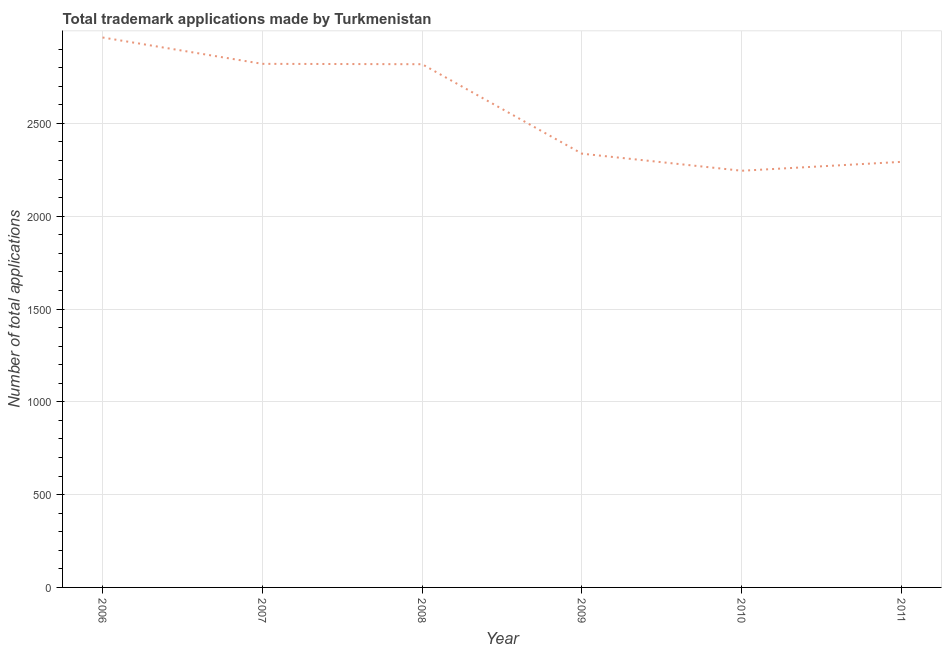What is the number of trademark applications in 2011?
Give a very brief answer. 2293. Across all years, what is the maximum number of trademark applications?
Keep it short and to the point. 2963. Across all years, what is the minimum number of trademark applications?
Your answer should be very brief. 2245. In which year was the number of trademark applications maximum?
Your answer should be very brief. 2006. In which year was the number of trademark applications minimum?
Offer a very short reply. 2010. What is the sum of the number of trademark applications?
Your answer should be compact. 1.55e+04. What is the difference between the number of trademark applications in 2008 and 2010?
Keep it short and to the point. 574. What is the average number of trademark applications per year?
Offer a terse response. 2579.67. What is the median number of trademark applications?
Give a very brief answer. 2578. In how many years, is the number of trademark applications greater than 1600 ?
Your response must be concise. 6. What is the ratio of the number of trademark applications in 2008 to that in 2011?
Offer a very short reply. 1.23. Is the difference between the number of trademark applications in 2009 and 2011 greater than the difference between any two years?
Give a very brief answer. No. What is the difference between the highest and the second highest number of trademark applications?
Your answer should be very brief. 142. What is the difference between the highest and the lowest number of trademark applications?
Offer a terse response. 718. Are the values on the major ticks of Y-axis written in scientific E-notation?
Make the answer very short. No. Does the graph contain any zero values?
Your answer should be compact. No. What is the title of the graph?
Give a very brief answer. Total trademark applications made by Turkmenistan. What is the label or title of the Y-axis?
Make the answer very short. Number of total applications. What is the Number of total applications of 2006?
Ensure brevity in your answer.  2963. What is the Number of total applications in 2007?
Make the answer very short. 2821. What is the Number of total applications of 2008?
Offer a very short reply. 2819. What is the Number of total applications in 2009?
Make the answer very short. 2337. What is the Number of total applications of 2010?
Provide a short and direct response. 2245. What is the Number of total applications of 2011?
Make the answer very short. 2293. What is the difference between the Number of total applications in 2006 and 2007?
Provide a short and direct response. 142. What is the difference between the Number of total applications in 2006 and 2008?
Ensure brevity in your answer.  144. What is the difference between the Number of total applications in 2006 and 2009?
Give a very brief answer. 626. What is the difference between the Number of total applications in 2006 and 2010?
Offer a very short reply. 718. What is the difference between the Number of total applications in 2006 and 2011?
Your answer should be very brief. 670. What is the difference between the Number of total applications in 2007 and 2009?
Your answer should be very brief. 484. What is the difference between the Number of total applications in 2007 and 2010?
Provide a short and direct response. 576. What is the difference between the Number of total applications in 2007 and 2011?
Your response must be concise. 528. What is the difference between the Number of total applications in 2008 and 2009?
Offer a very short reply. 482. What is the difference between the Number of total applications in 2008 and 2010?
Provide a short and direct response. 574. What is the difference between the Number of total applications in 2008 and 2011?
Provide a succinct answer. 526. What is the difference between the Number of total applications in 2009 and 2010?
Provide a succinct answer. 92. What is the difference between the Number of total applications in 2010 and 2011?
Keep it short and to the point. -48. What is the ratio of the Number of total applications in 2006 to that in 2008?
Offer a very short reply. 1.05. What is the ratio of the Number of total applications in 2006 to that in 2009?
Ensure brevity in your answer.  1.27. What is the ratio of the Number of total applications in 2006 to that in 2010?
Ensure brevity in your answer.  1.32. What is the ratio of the Number of total applications in 2006 to that in 2011?
Your answer should be very brief. 1.29. What is the ratio of the Number of total applications in 2007 to that in 2008?
Make the answer very short. 1. What is the ratio of the Number of total applications in 2007 to that in 2009?
Provide a short and direct response. 1.21. What is the ratio of the Number of total applications in 2007 to that in 2010?
Ensure brevity in your answer.  1.26. What is the ratio of the Number of total applications in 2007 to that in 2011?
Your response must be concise. 1.23. What is the ratio of the Number of total applications in 2008 to that in 2009?
Your response must be concise. 1.21. What is the ratio of the Number of total applications in 2008 to that in 2010?
Your response must be concise. 1.26. What is the ratio of the Number of total applications in 2008 to that in 2011?
Provide a short and direct response. 1.23. What is the ratio of the Number of total applications in 2009 to that in 2010?
Make the answer very short. 1.04. What is the ratio of the Number of total applications in 2009 to that in 2011?
Offer a terse response. 1.02. 